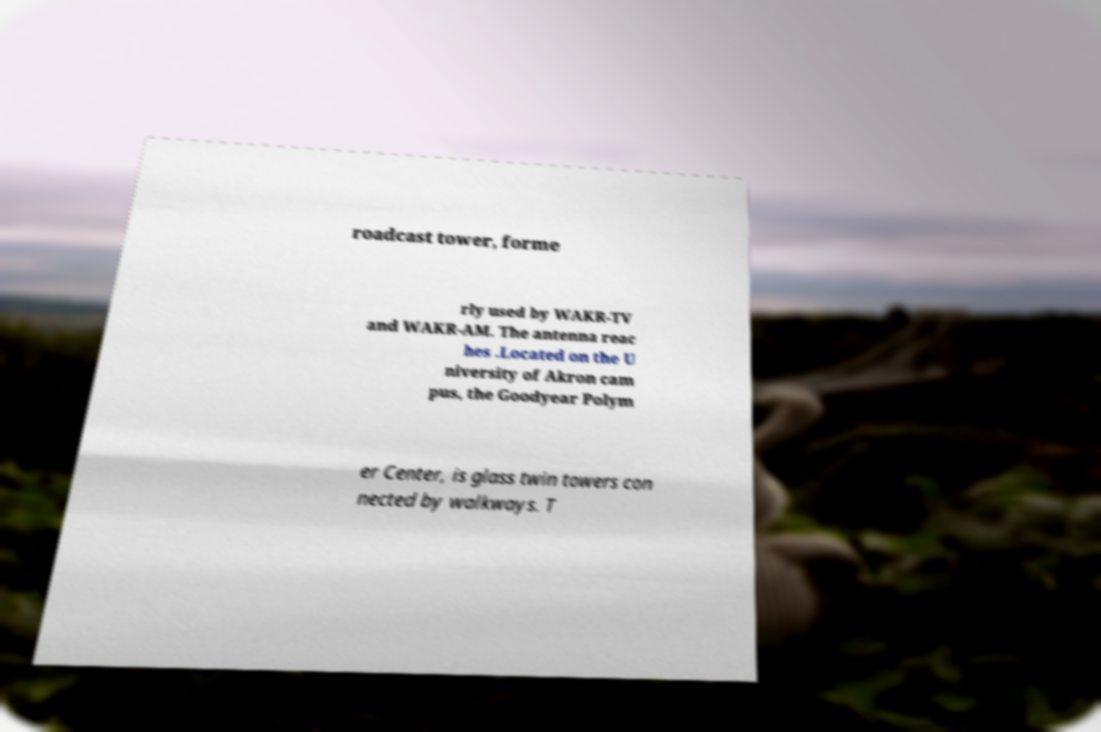There's text embedded in this image that I need extracted. Can you transcribe it verbatim? roadcast tower, forme rly used by WAKR-TV and WAKR-AM. The antenna reac hes .Located on the U niversity of Akron cam pus, the Goodyear Polym er Center, is glass twin towers con nected by walkways. T 